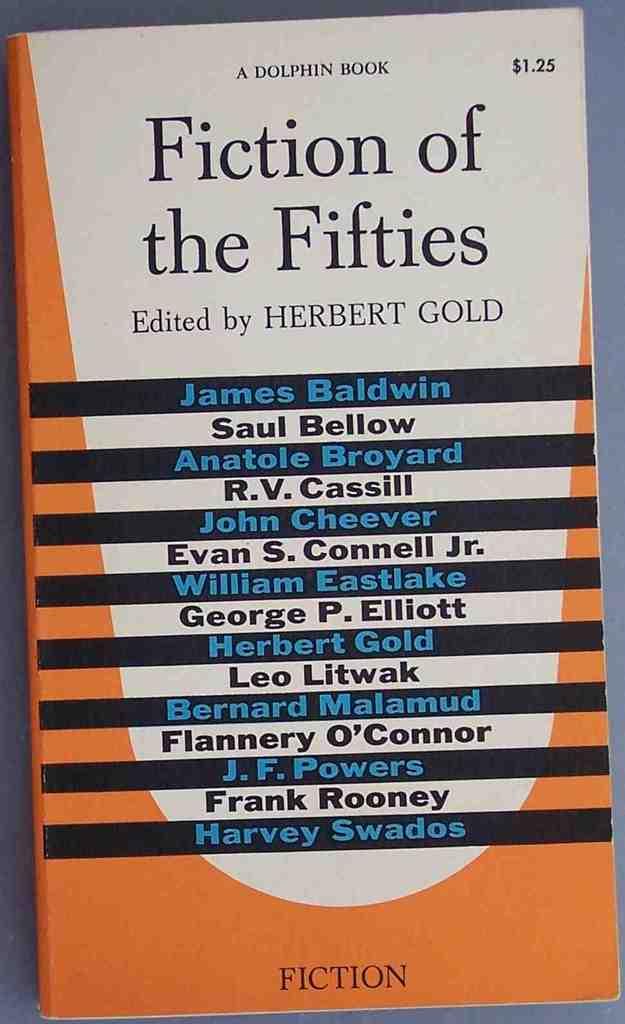Who edited this book?
Your answer should be compact. Herbert gold. 